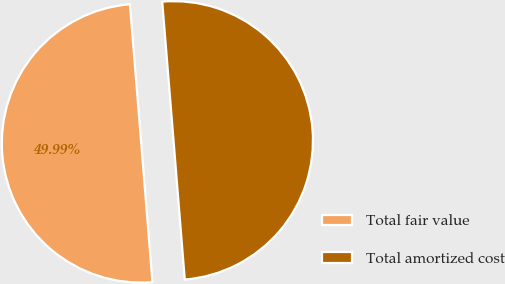<chart> <loc_0><loc_0><loc_500><loc_500><pie_chart><fcel>Total fair value<fcel>Total amortized cost<nl><fcel>49.99%<fcel>50.01%<nl></chart> 